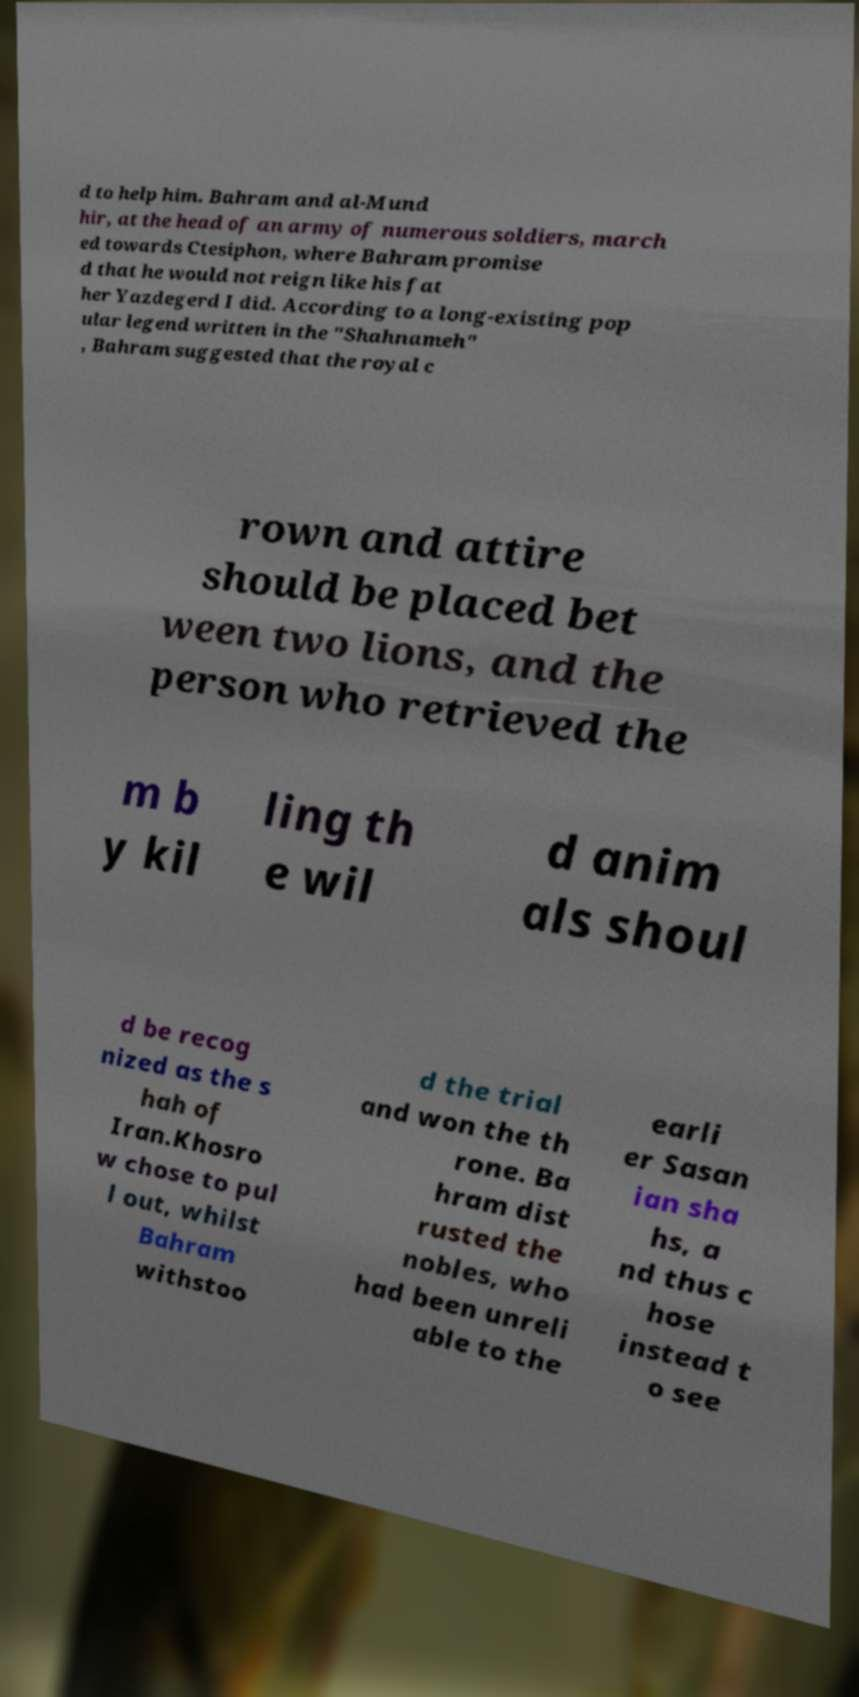Please read and relay the text visible in this image. What does it say? d to help him. Bahram and al-Mund hir, at the head of an army of numerous soldiers, march ed towards Ctesiphon, where Bahram promise d that he would not reign like his fat her Yazdegerd I did. According to a long-existing pop ular legend written in the "Shahnameh" , Bahram suggested that the royal c rown and attire should be placed bet ween two lions, and the person who retrieved the m b y kil ling th e wil d anim als shoul d be recog nized as the s hah of Iran.Khosro w chose to pul l out, whilst Bahram withstoo d the trial and won the th rone. Ba hram dist rusted the nobles, who had been unreli able to the earli er Sasan ian sha hs, a nd thus c hose instead t o see 